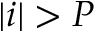<formula> <loc_0><loc_0><loc_500><loc_500>| i | > P</formula> 